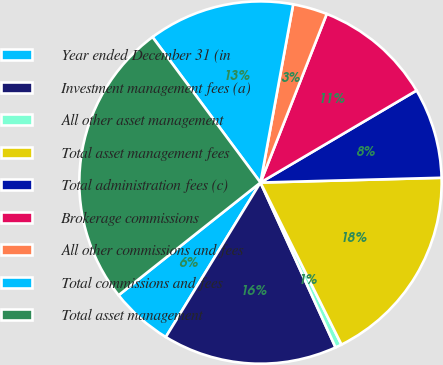Convert chart to OTSL. <chart><loc_0><loc_0><loc_500><loc_500><pie_chart><fcel>Year ended December 31 (in<fcel>Investment management fees (a)<fcel>All other asset management<fcel>Total asset management fees<fcel>Total administration fees (c)<fcel>Brokerage commissions<fcel>All other commissions and fees<fcel>Total commissions and fees<fcel>Total asset management<nl><fcel>5.57%<fcel>15.55%<fcel>0.58%<fcel>18.04%<fcel>8.06%<fcel>10.56%<fcel>3.07%<fcel>13.05%<fcel>25.52%<nl></chart> 